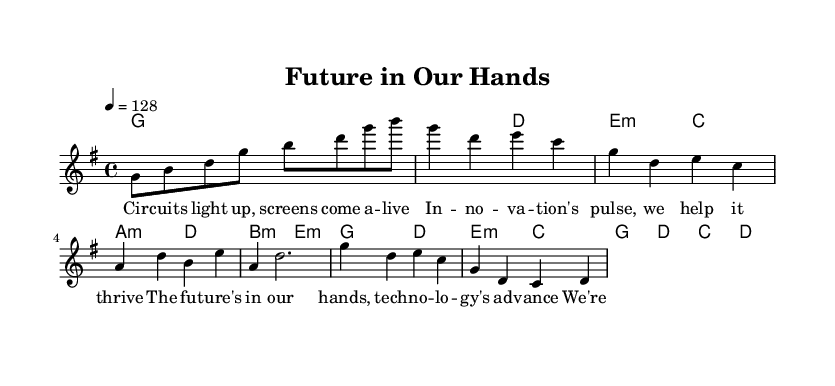What is the key signature of this music? The key signature is G major, which contains one sharp (F#). This can be identified in the global section of the code where the key is defined as "\key g \major".
Answer: G major What is the time signature of this music? The time signature is four-four, which is indicated by "\time 4/4" in the global section. This means there are four beats per measure and each quarter note gets one beat.
Answer: Four-four What is the tempo of this music? The tempo is 128 beats per minute, as noted by "\tempo 4 = 128" in the global section, indicating how fast the piece should be played.
Answer: 128 How many measures are in the Chorus section? The Chorus section contains four measures, as each line of the melody for the Chorus consists of one measure, indicated in the melody block. Counting these, we see there are four measures.
Answer: Four What is the overall structure of the song? The structure of the song is Intro, Verse, Pre-Chorus, and Chorus, as delineated in the comment markings in the melody block. This shows how the song progresses through different musical ideas.
Answer: Verse, Pre-Chorus, Chorus What themes are celebrated in the lyrics? The lyrics celebrate themes of innovation and technology, as seen in phrases like "innovation's pulse, we help it thrive" and "the future's in our hands", which emphasize advancement in these areas.
Answer: Innovation and technology How does the harmony change from the Verse to the Pre-Chorus? In the Verse, the harmony progresses from G to D to E minor and C, whereas in the Pre-Chorus it shifts to A minor and D before resolving to B minor and E minor. This shows a movement from stable to more complex harmonies in the song structure.
Answer: A minor, D, B minor, E minor 